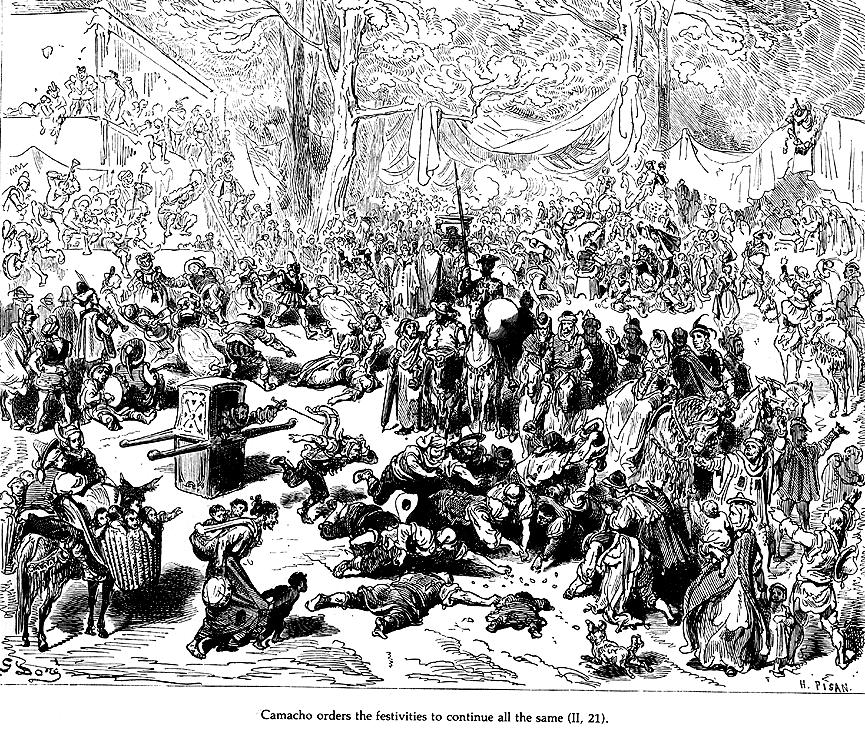What's happening in the scene?
 This is a black and white illustration that vividly brings to life a scene from the novel Don Quixote by Miguel de Cervantes. The setting is a forest, teeming with a large group of people who have gathered around a central figure, Camacho. The crowd seems to be in a state of anticipation, their attention riveted on Camacho as he orders the festivities to continue. The illustration, rendered in the style of a woodcut, is highly detailed, with each figure and object meticulously depicted. Despite the absence of color, the image is rich in texture and depth, creating a sense of dynamism and movement. The art genre is historical fiction, and the image successfully transports the viewer back in time, immersing them in the narrative of the novel. The text "Camacho orders the festivities to continue all the same (p. 21)" is inscribed at the bottom, providing context to the scene. 